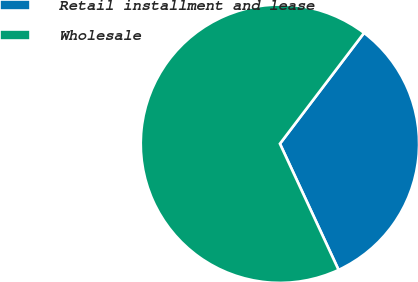Convert chart. <chart><loc_0><loc_0><loc_500><loc_500><pie_chart><fcel>Retail installment and lease<fcel>Wholesale<nl><fcel>32.74%<fcel>67.26%<nl></chart> 